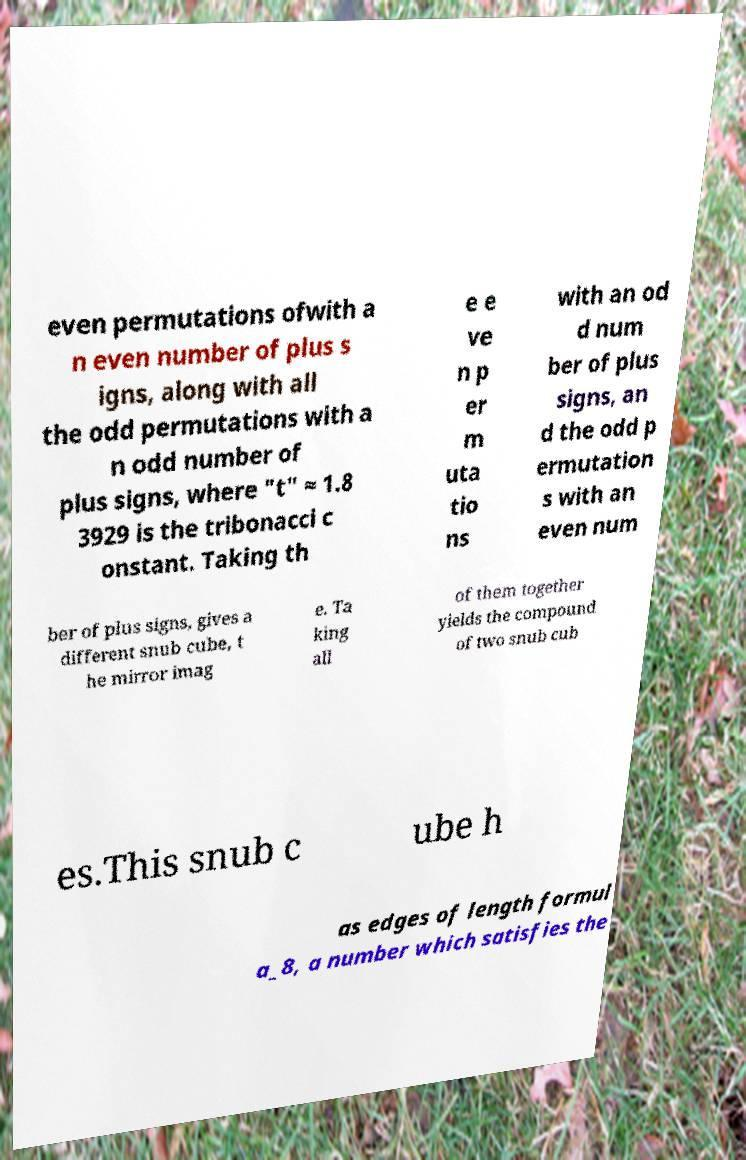Please identify and transcribe the text found in this image. even permutations ofwith a n even number of plus s igns, along with all the odd permutations with a n odd number of plus signs, where "t" ≈ 1.8 3929 is the tribonacci c onstant. Taking th e e ve n p er m uta tio ns with an od d num ber of plus signs, an d the odd p ermutation s with an even num ber of plus signs, gives a different snub cube, t he mirror imag e. Ta king all of them together yields the compound of two snub cub es.This snub c ube h as edges of length formul a_8, a number which satisfies the 